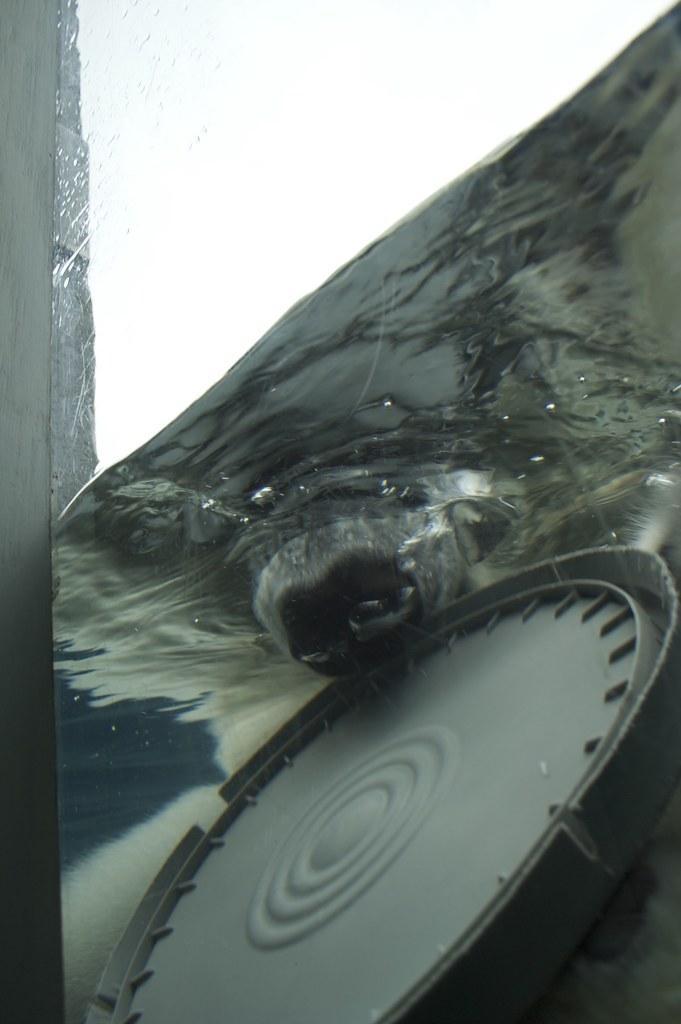Describe this image in one or two sentences. In this image, we can see some water with the animal’s mouth and an object. We can also see an object on the left. 